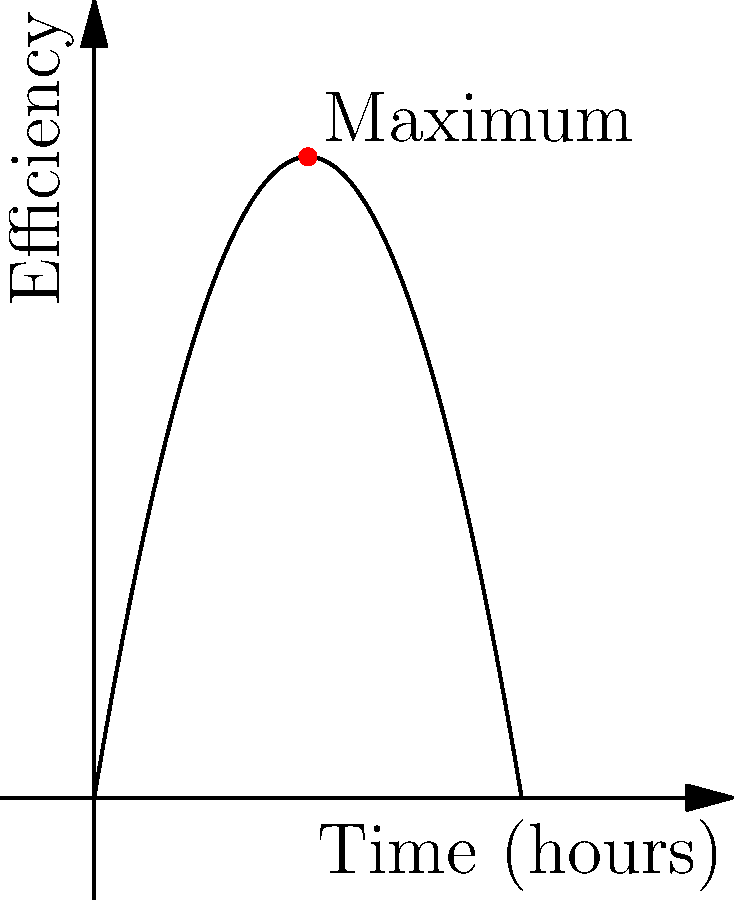The efficiency of support agents in handling customer inquiries can be modeled by the function $E(t) = -0.5t^2 + 6t$, where $E$ represents the efficiency score and $t$ represents the time in hours since the start of the shift. Find the maximum efficiency score and the time at which it occurs. To find the maximum efficiency point, we need to follow these steps:

1) First, we need to find the derivative of the function:
   $E'(t) = -t + 6$

2) To find the critical point, set the derivative equal to zero:
   $-t + 6 = 0$
   $t = 6$

3) This critical point (t = 6) could be a maximum or minimum. To confirm it's a maximum, we can check the second derivative:
   $E''(t) = -1$

   Since $E''(t)$ is negative, the critical point is indeed a maximum.

4) To find the maximum efficiency score, we plug t = 6 into the original function:
   $E(6) = -0.5(6)^2 + 6(6)$
   $= -0.5(36) + 36$
   $= -18 + 36$
   $= 18$

Therefore, the maximum efficiency score is 18, occurring 6 hours into the shift.
Answer: Maximum efficiency score: 18; Time: 6 hours 